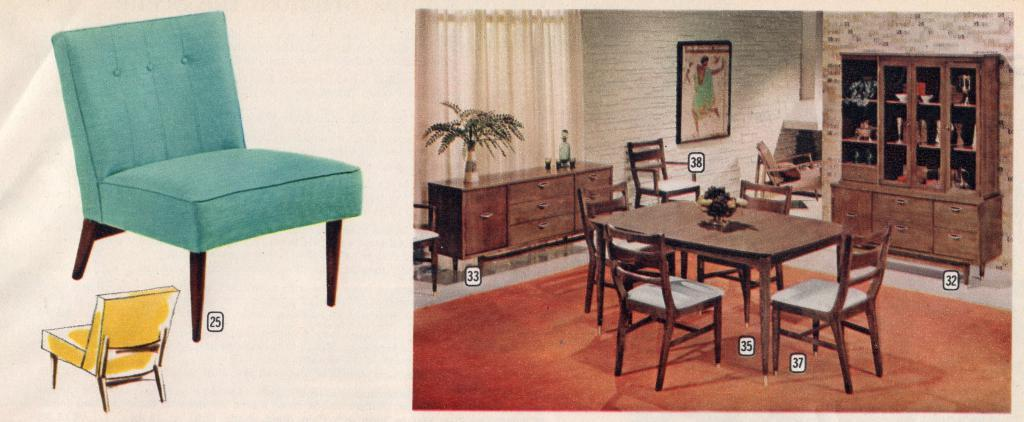What type of furniture is present in the image? There are chairs and a table in the image. What other objects can be seen in the image? There is a drawer, a cabinet, and a curtain in the image. Is there any decorative item on the wall in the image? Yes, there is a photo frame on the wall in the image. Can you see any steam coming from the chairs in the image? There is no steam present in the image; it features chairs, a table, a drawer, a cabinet, a curtain, and a photo frame. 